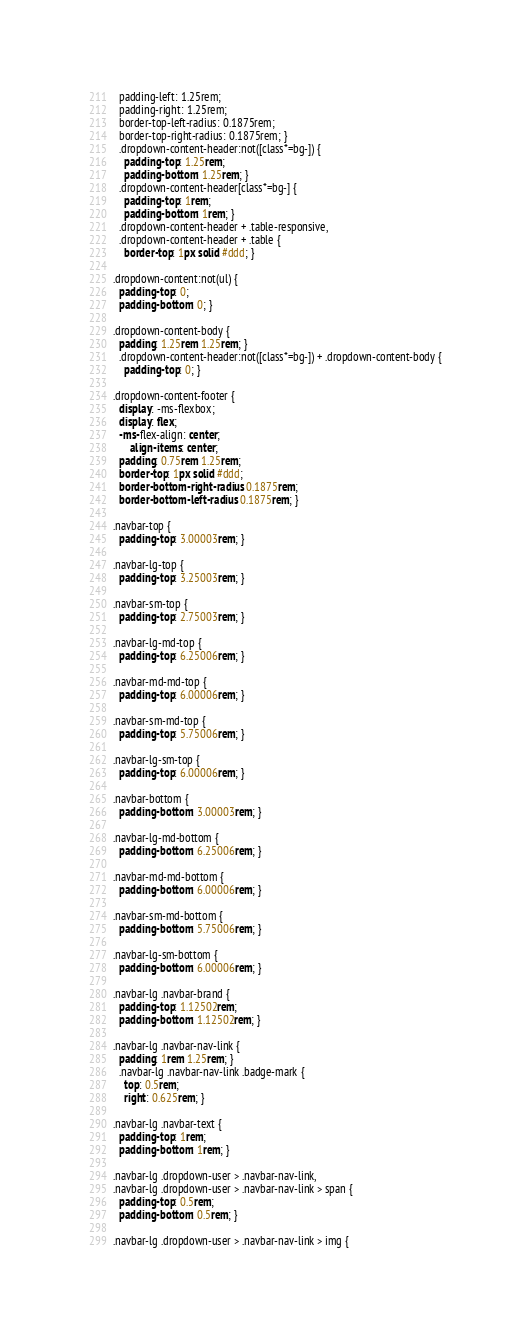Convert code to text. <code><loc_0><loc_0><loc_500><loc_500><_CSS_>  padding-left: 1.25rem;
  padding-right: 1.25rem;
  border-top-left-radius: 0.1875rem;
  border-top-right-radius: 0.1875rem; }
  .dropdown-content-header:not([class*=bg-]) {
    padding-top: 1.25rem;
    padding-bottom: 1.25rem; }
  .dropdown-content-header[class*=bg-] {
    padding-top: 1rem;
    padding-bottom: 1rem; }
  .dropdown-content-header + .table-responsive,
  .dropdown-content-header + .table {
    border-top: 1px solid #ddd; }

.dropdown-content:not(ul) {
  padding-top: 0;
  padding-bottom: 0; }

.dropdown-content-body {
  padding: 1.25rem 1.25rem; }
  .dropdown-content-header:not([class*=bg-]) + .dropdown-content-body {
    padding-top: 0; }

.dropdown-content-footer {
  display: -ms-flexbox;
  display: flex;
  -ms-flex-align: center;
      align-items: center;
  padding: 0.75rem 1.25rem;
  border-top: 1px solid #ddd;
  border-bottom-right-radius: 0.1875rem;
  border-bottom-left-radius: 0.1875rem; }

.navbar-top {
  padding-top: 3.00003rem; }

.navbar-lg-top {
  padding-top: 3.25003rem; }

.navbar-sm-top {
  padding-top: 2.75003rem; }

.navbar-lg-md-top {
  padding-top: 6.25006rem; }

.navbar-md-md-top {
  padding-top: 6.00006rem; }

.navbar-sm-md-top {
  padding-top: 5.75006rem; }

.navbar-lg-sm-top {
  padding-top: 6.00006rem; }

.navbar-bottom {
  padding-bottom: 3.00003rem; }

.navbar-lg-md-bottom {
  padding-bottom: 6.25006rem; }

.navbar-md-md-bottom {
  padding-bottom: 6.00006rem; }

.navbar-sm-md-bottom {
  padding-bottom: 5.75006rem; }

.navbar-lg-sm-bottom {
  padding-bottom: 6.00006rem; }

.navbar-lg .navbar-brand {
  padding-top: 1.12502rem;
  padding-bottom: 1.12502rem; }

.navbar-lg .navbar-nav-link {
  padding: 1rem 1.25rem; }
  .navbar-lg .navbar-nav-link .badge-mark {
    top: 0.5rem;
    right: 0.625rem; }

.navbar-lg .navbar-text {
  padding-top: 1rem;
  padding-bottom: 1rem; }

.navbar-lg .dropdown-user > .navbar-nav-link,
.navbar-lg .dropdown-user > .navbar-nav-link > span {
  padding-top: 0.5rem;
  padding-bottom: 0.5rem; }

.navbar-lg .dropdown-user > .navbar-nav-link > img {</code> 